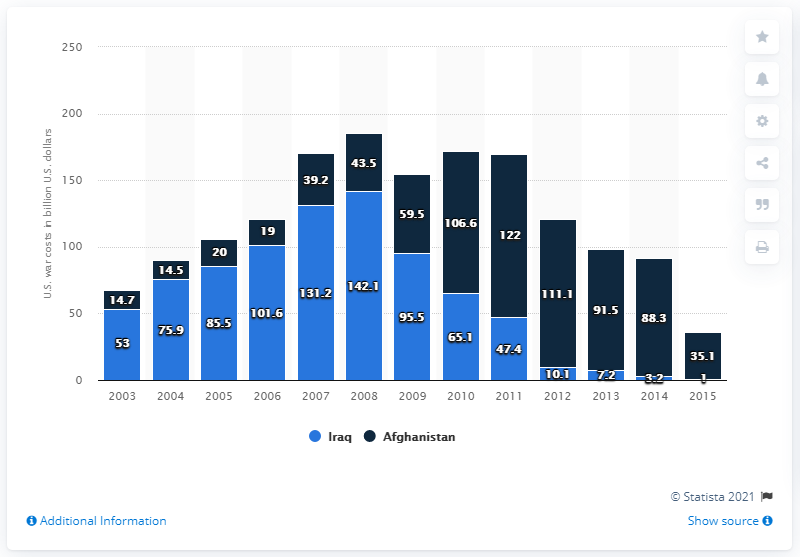Outline some significant characteristics in this image. In 2013, the cost of the war in Afghanistan was approximately $91.5 billion. 